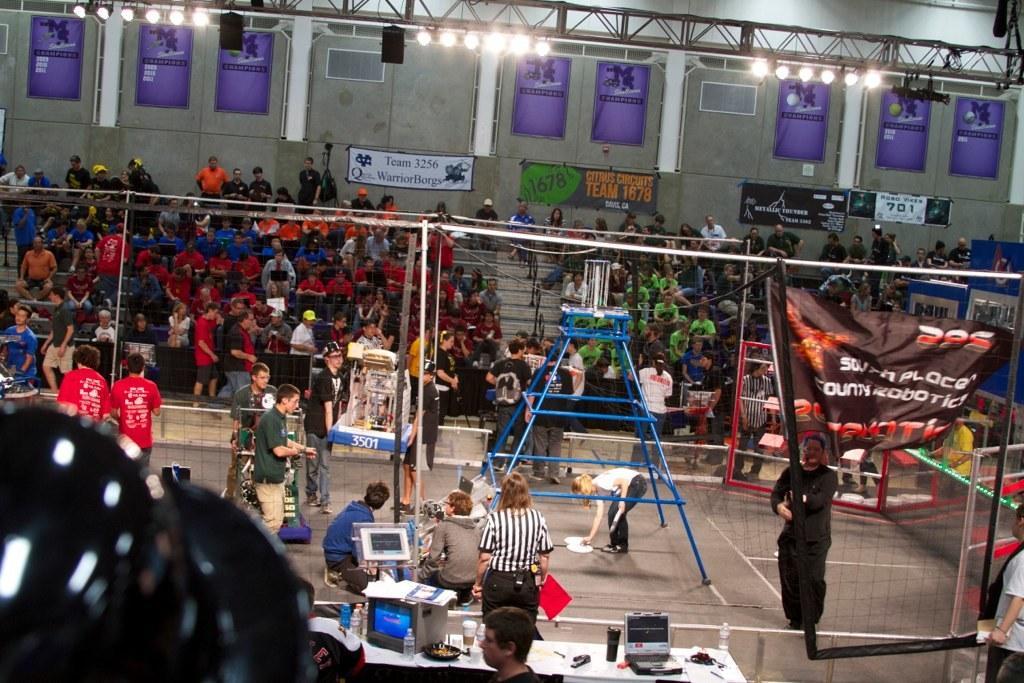Could you give a brief overview of what you see in this image? In this picture I can see there are crowd of people sitting on the chairs and there are some people standing here and there are lights attached on the ceiling. 